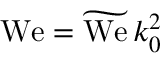<formula> <loc_0><loc_0><loc_500><loc_500>{ W e } = \widetilde { W e } \, k _ { 0 } ^ { 2 }</formula> 